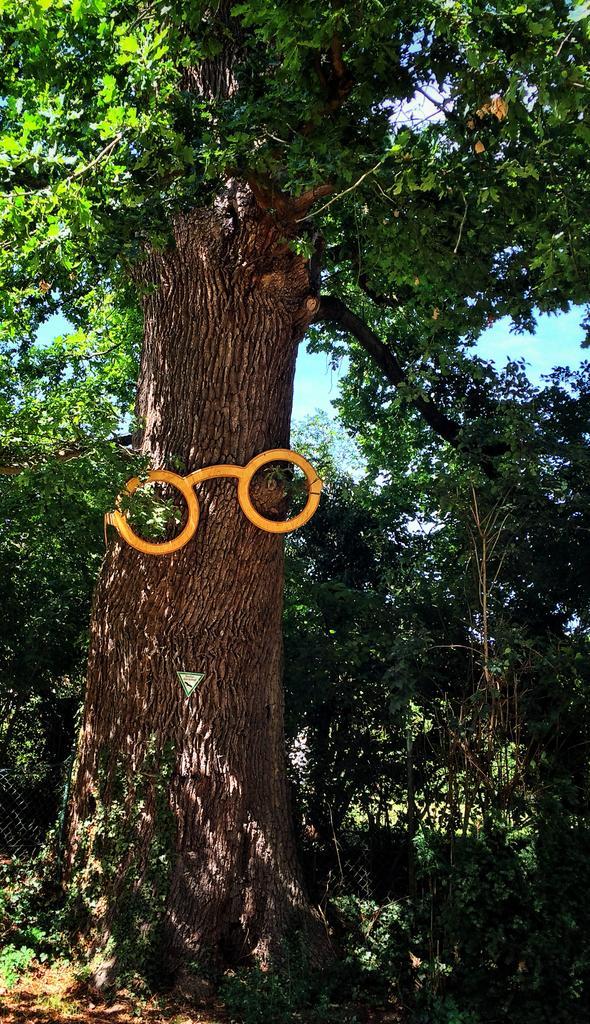How would you summarize this image in a sentence or two? In this image I can see trees in green color. Background I can see sky in blue color. 